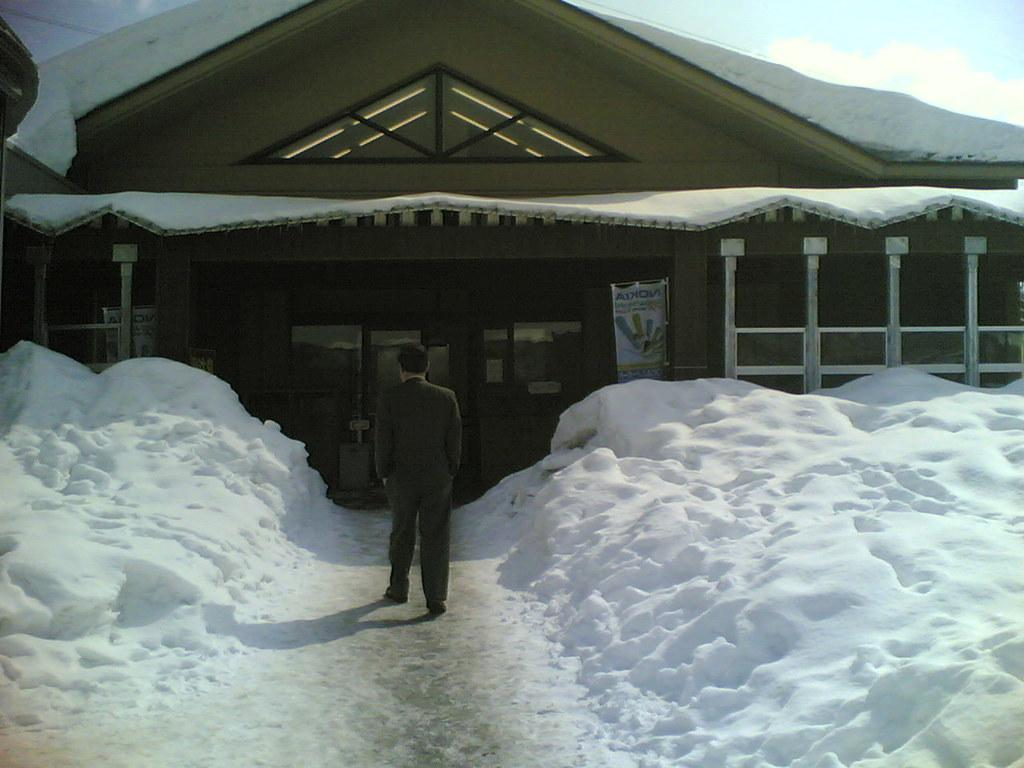What is the main subject of the image? There is a person standing in the image. What is the person wearing? The person is wearing a coat. What can be seen in the background of the image? There is a house behind the person. What type of weather is depicted in the image? Snow is present on both the right and left sides of the image. How does the beginner learn to exchange parts in the image? There is no exchange or parts to learn in the image; it simply depicts a person standing in the snow with a house in the background. 